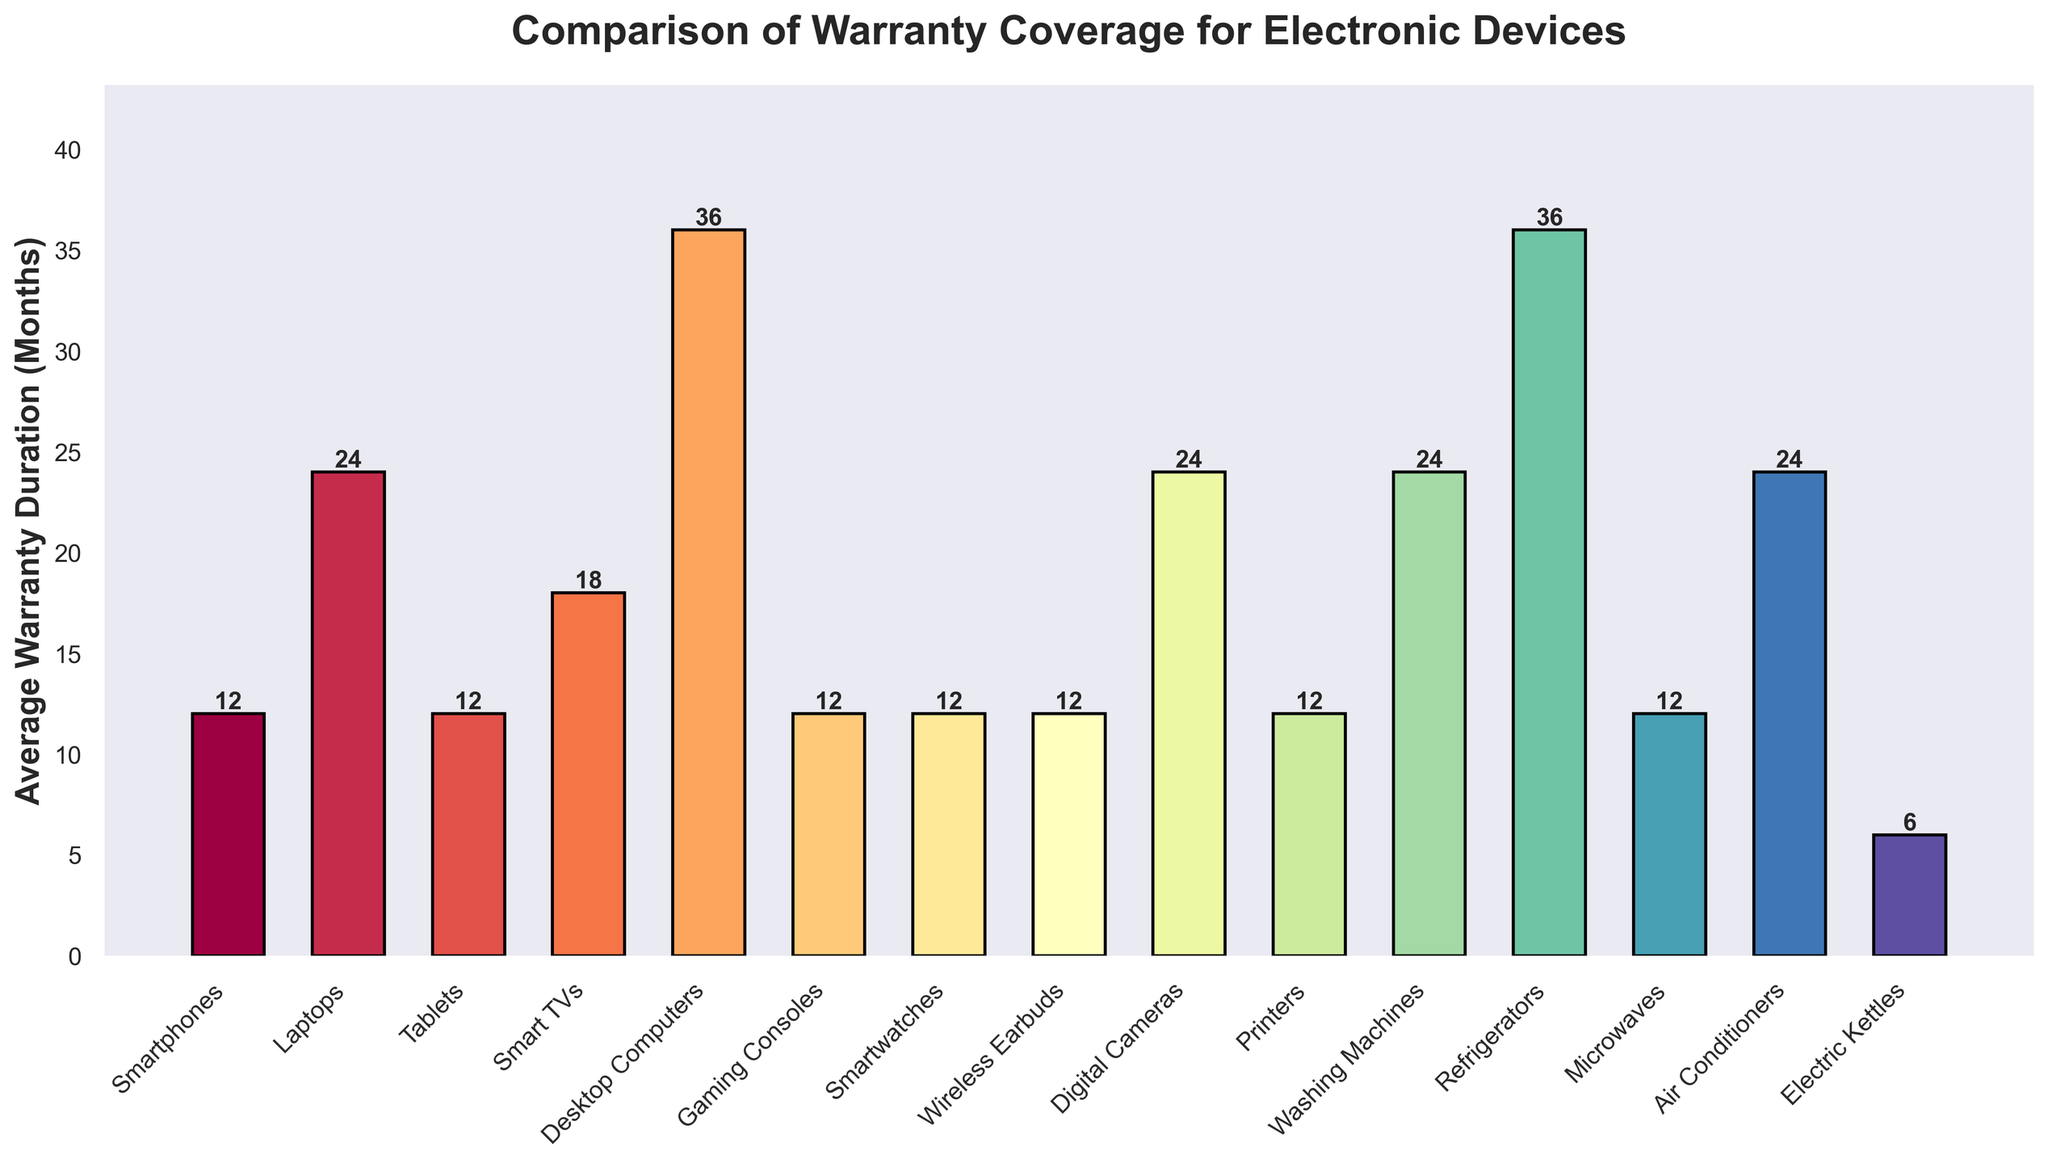What device has the longest warranty duration? Look at the height of each bar. The highest bar corresponds to the longest warranty duration.
Answer: Desktop Computers and Refrigerators Which devices have the shortest warranty duration? Look for the shortest bars in the chart.
Answer: Electric Kettles How many months longer is the warranty for Desktop Computers than for Smartphones? Find the warranty duration for Desktop Computers (36 months) and Smartphones (12 months). Subtract the shorter duration from the longer one: 36 - 12.
Answer: 24 Are there any devices with the same warranty duration? Compare the height of bars to see if any two or more bars are of equal height.
Answer: Yes, six devices: Smartphones, Tablets, Gaming Consoles, Smartwatches, Wireless Earbuds, and Printers all have 12 months What is the combined warranty duration for Digital Cameras and Laptops? Find the warranty duration for Digital Cameras (24 months) and Laptops (24 months). Add them together: 24 + 24.
Answer: 48 Is the warranty duration for Smart TVs more or less than that for Tablets? Compare the height of the bar for Smart TVs (18 months) with the height of the bar for Tablets (12 months).
Answer: More How many devices have a warranty duration of exactly 12 months? Count the number of bars that reach the height corresponding to 12 months.
Answer: 7 Which devices have a warranty duration greater than 12 months but less than 24 months? Look for bars with heights greater than 12 but less than 24 months.
Answer: Smart TVs Is there a larger difference in warranty duration between Smart TVs and Laptops or between Washing Machines and Microwaves? Calculate the differences: Laptops (24) - Smart TVs (18) = 6, and Washing Machines (24) - Microwaves (12) = 12. Compare the two differences.
Answer: Washing Machines and Microwaves What is the average warranty duration of all devices combined? Sum all warranty durations and divide by the number of devices: (12 + 24 + 12 + 18 + 36 + 12 + 12 + 12 + 24 + 12 + 24 + 36 + 12 + 24 + 6) / 15 = 21
Answer: 21 